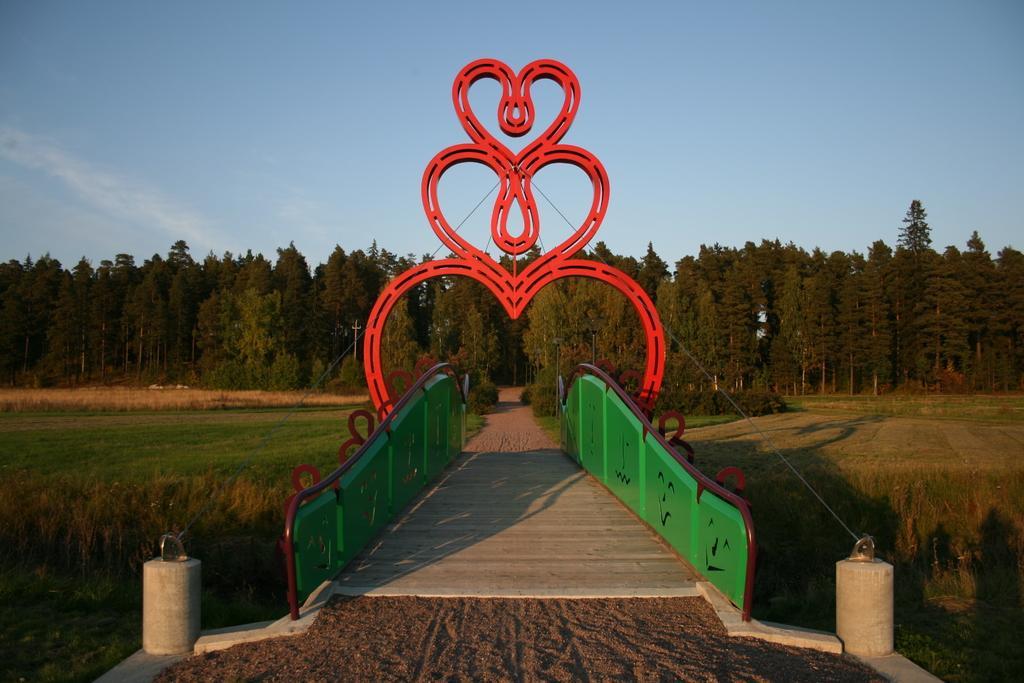Can you describe this image briefly? In this picture I can observe a bridge in the middle of the picture. In the background I can observe trees and sky. 